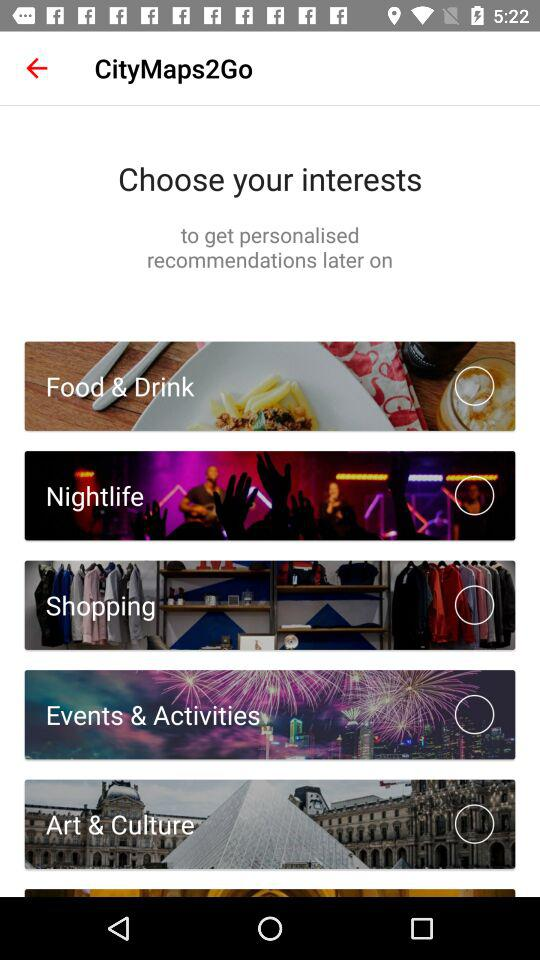What is the application Name?
When the provided information is insufficient, respond with <no answer>. <no answer> 